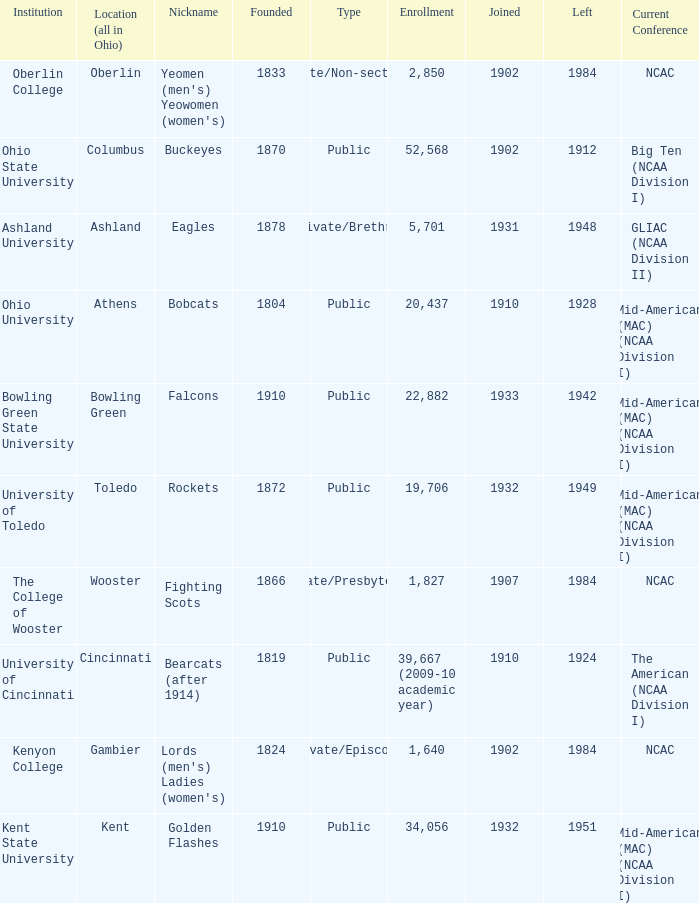What is the type of institution in Kent State University? Public. 